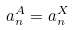<formula> <loc_0><loc_0><loc_500><loc_500>a _ { n } ^ { A } = a _ { n } ^ { X }</formula> 